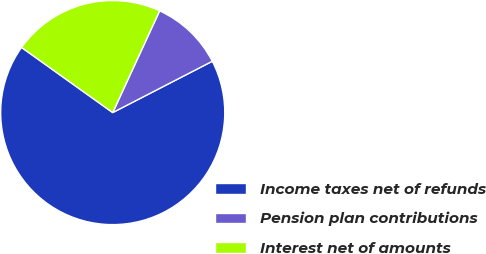<chart> <loc_0><loc_0><loc_500><loc_500><pie_chart><fcel>Income taxes net of refunds<fcel>Pension plan contributions<fcel>Interest net of amounts<nl><fcel>67.45%<fcel>10.55%<fcel>22.0%<nl></chart> 